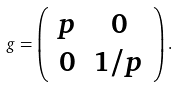<formula> <loc_0><loc_0><loc_500><loc_500>g = \left ( \begin{array} { c c } p & 0 \\ 0 & 1 / p \end{array} \right ) .</formula> 